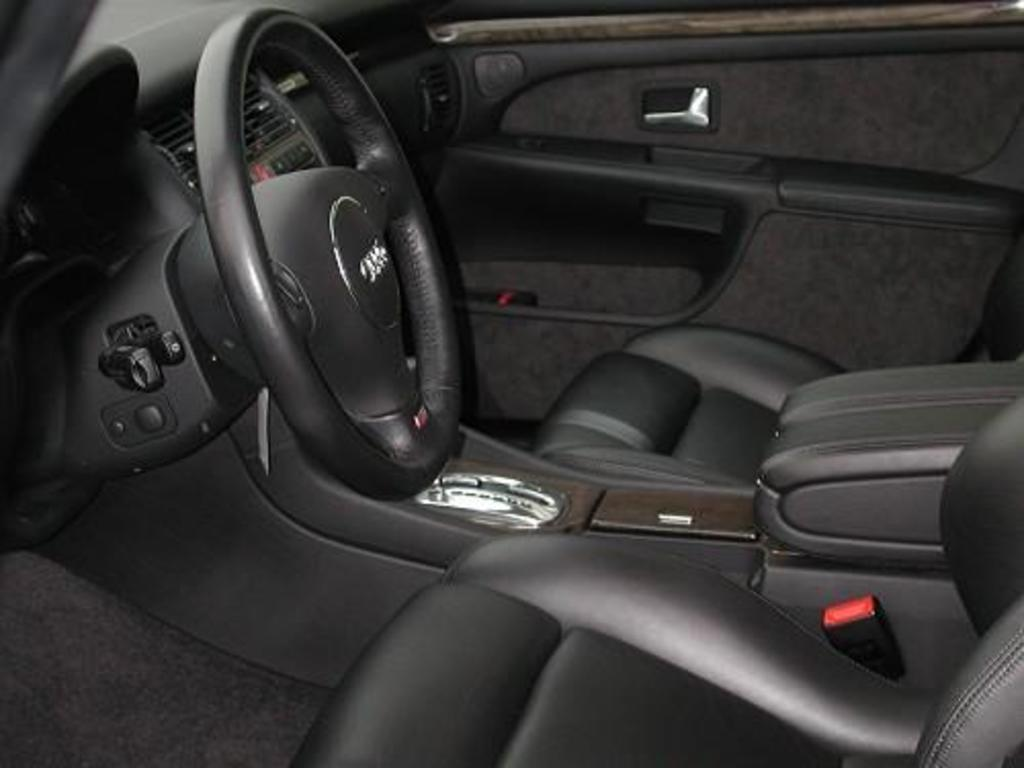What type of setting is depicted in the image? The image is an inside view of a car. What is the main control device in the car? There is a steering wheel in the image. What are the seats used for in the car? The seats are used for passengers to sit in the car. What type of thrill can be experienced from the arch in the image? There is no arch present in the image; it is an inside view of a car. 